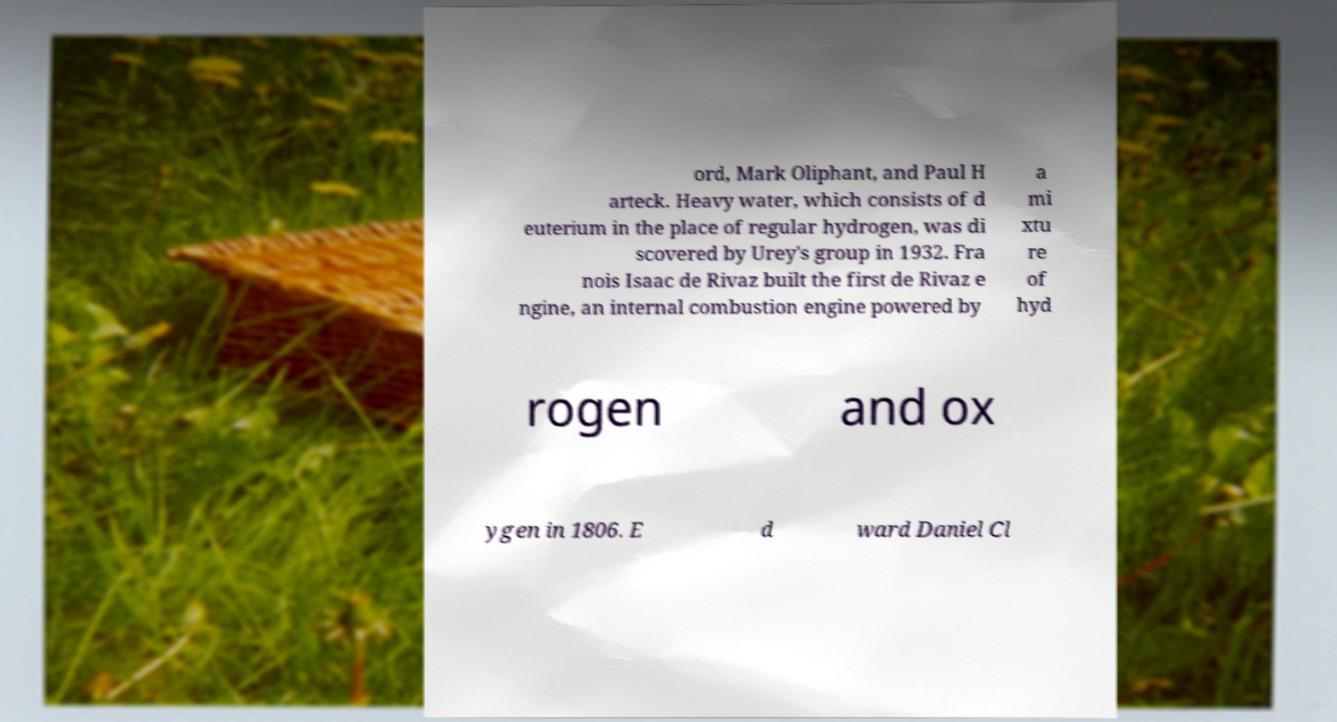Could you assist in decoding the text presented in this image and type it out clearly? ord, Mark Oliphant, and Paul H arteck. Heavy water, which consists of d euterium in the place of regular hydrogen, was di scovered by Urey's group in 1932. Fra nois Isaac de Rivaz built the first de Rivaz e ngine, an internal combustion engine powered by a mi xtu re of hyd rogen and ox ygen in 1806. E d ward Daniel Cl 